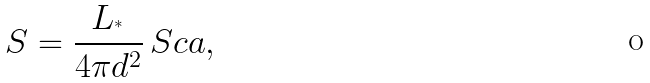<formula> <loc_0><loc_0><loc_500><loc_500>S = \frac { L _ { ^ { * } } } { 4 \pi d ^ { 2 } } \, { S c a } ,</formula> 